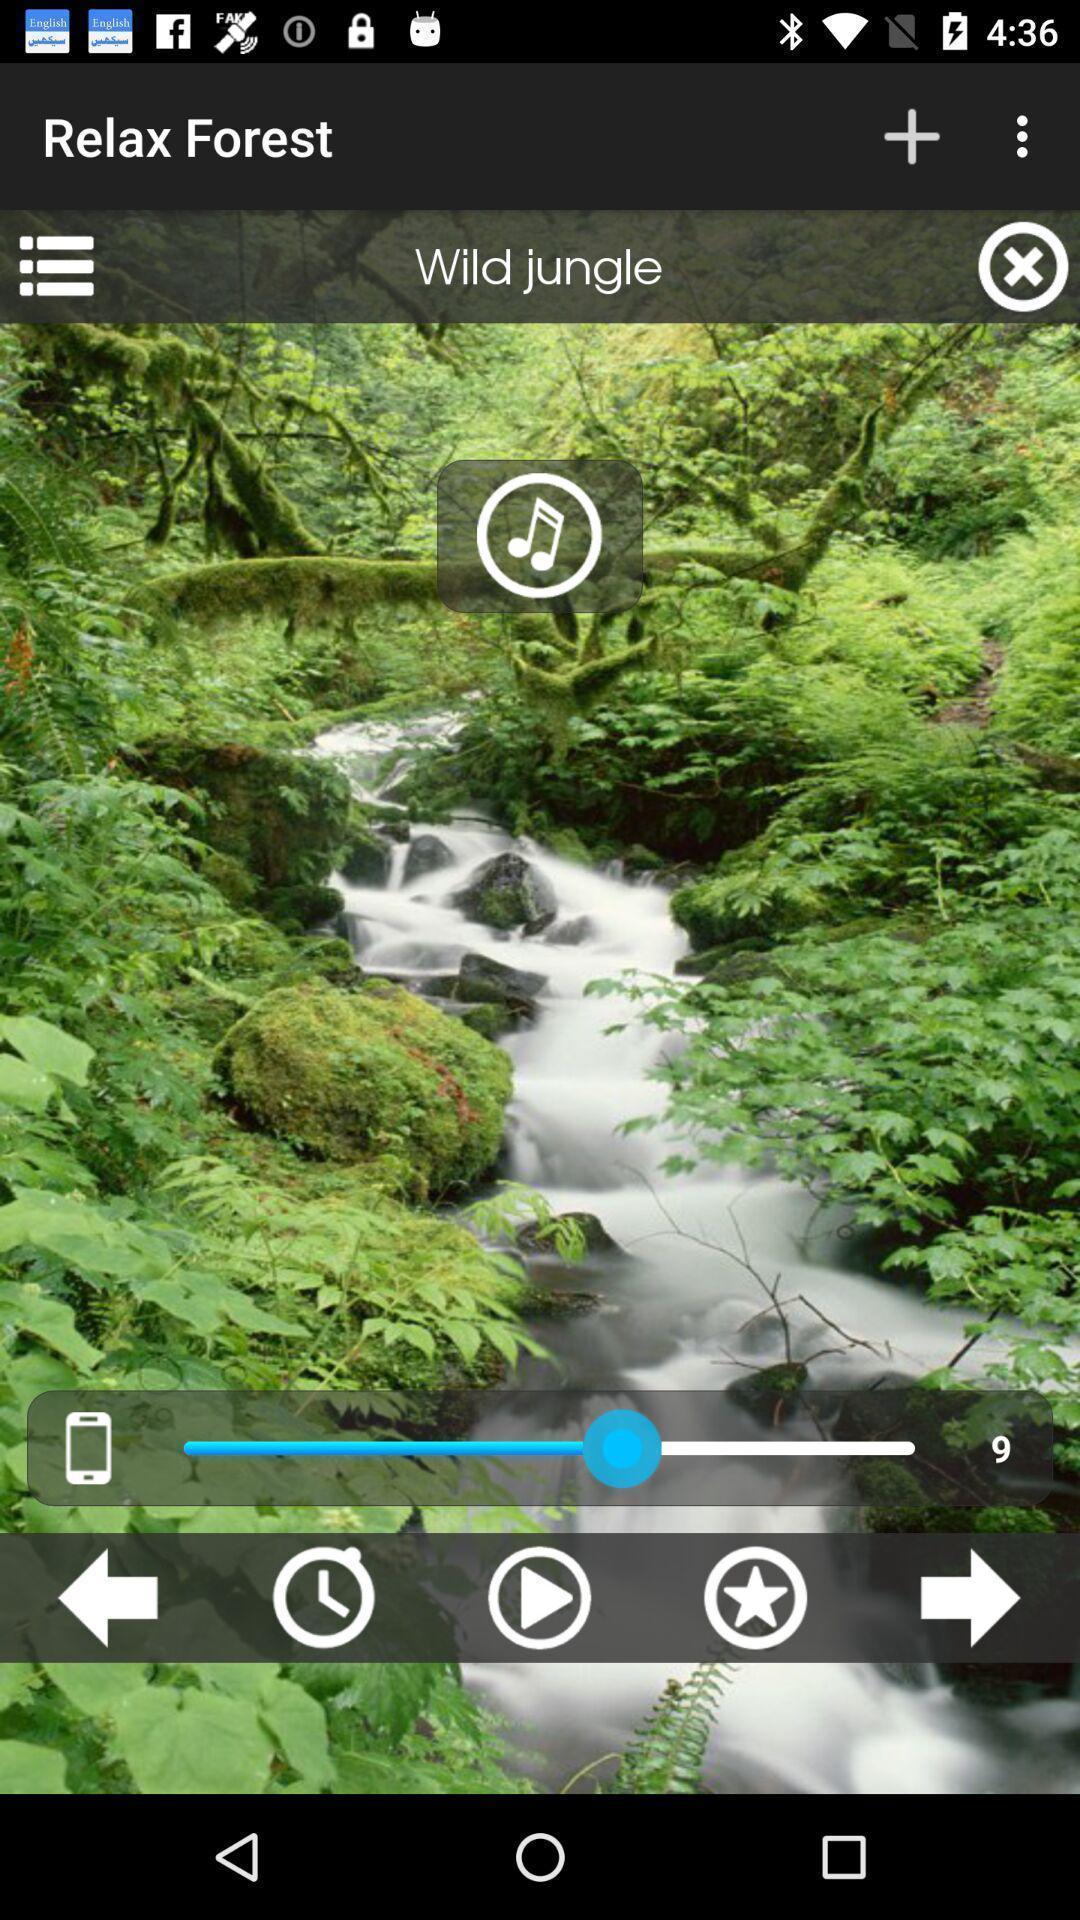Explain what's happening in this screen capture. Page showing an image with multiple options. 